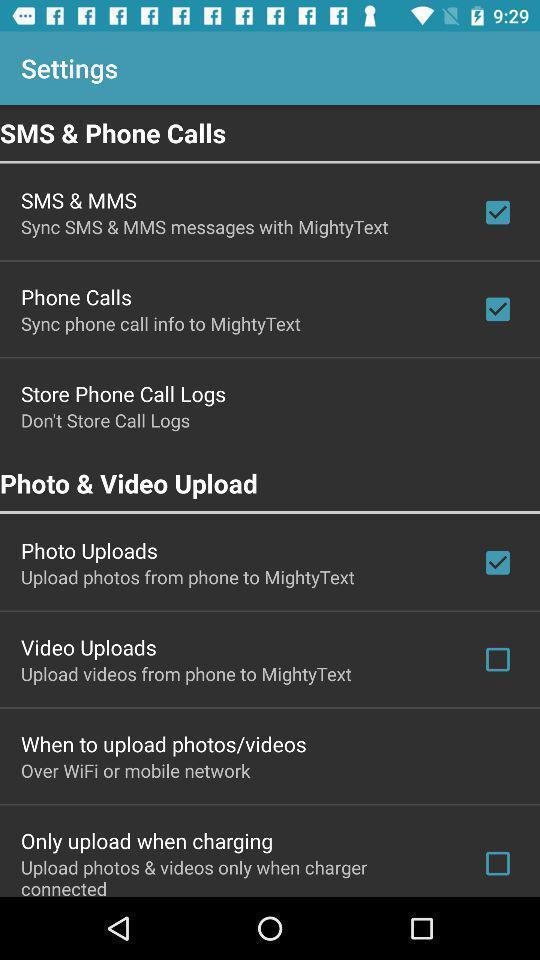Summarize the main components in this picture. Settings page displayed. 